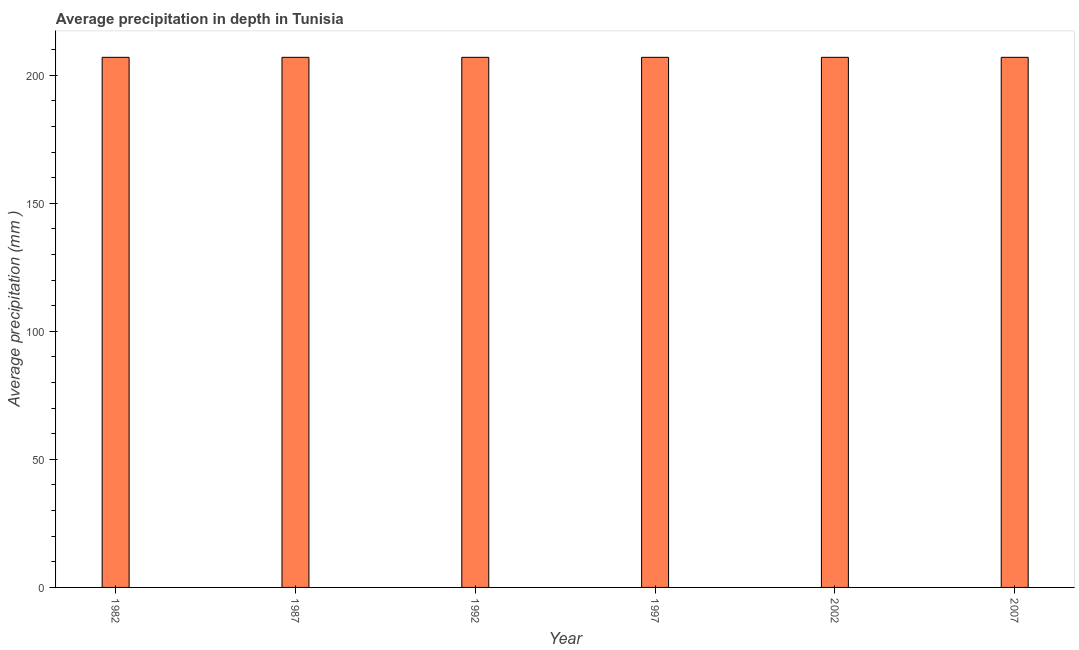Does the graph contain grids?
Offer a very short reply. No. What is the title of the graph?
Make the answer very short. Average precipitation in depth in Tunisia. What is the label or title of the Y-axis?
Offer a very short reply. Average precipitation (mm ). What is the average precipitation in depth in 1992?
Offer a terse response. 207. Across all years, what is the maximum average precipitation in depth?
Provide a short and direct response. 207. Across all years, what is the minimum average precipitation in depth?
Make the answer very short. 207. In which year was the average precipitation in depth maximum?
Keep it short and to the point. 1982. What is the sum of the average precipitation in depth?
Ensure brevity in your answer.  1242. What is the average average precipitation in depth per year?
Provide a short and direct response. 207. What is the median average precipitation in depth?
Give a very brief answer. 207. In how many years, is the average precipitation in depth greater than 110 mm?
Ensure brevity in your answer.  6. What is the difference between the highest and the lowest average precipitation in depth?
Your answer should be very brief. 0. How many bars are there?
Make the answer very short. 6. What is the Average precipitation (mm ) in 1982?
Ensure brevity in your answer.  207. What is the Average precipitation (mm ) of 1987?
Give a very brief answer. 207. What is the Average precipitation (mm ) of 1992?
Keep it short and to the point. 207. What is the Average precipitation (mm ) of 1997?
Your answer should be compact. 207. What is the Average precipitation (mm ) of 2002?
Offer a very short reply. 207. What is the Average precipitation (mm ) of 2007?
Provide a succinct answer. 207. What is the difference between the Average precipitation (mm ) in 1982 and 1987?
Make the answer very short. 0. What is the difference between the Average precipitation (mm ) in 1982 and 1992?
Your answer should be very brief. 0. What is the difference between the Average precipitation (mm ) in 1982 and 2002?
Provide a succinct answer. 0. What is the difference between the Average precipitation (mm ) in 1992 and 1997?
Offer a very short reply. 0. What is the difference between the Average precipitation (mm ) in 1992 and 2002?
Provide a short and direct response. 0. What is the difference between the Average precipitation (mm ) in 1997 and 2002?
Keep it short and to the point. 0. What is the difference between the Average precipitation (mm ) in 2002 and 2007?
Your response must be concise. 0. What is the ratio of the Average precipitation (mm ) in 1982 to that in 1987?
Keep it short and to the point. 1. What is the ratio of the Average precipitation (mm ) in 1982 to that in 1992?
Provide a short and direct response. 1. What is the ratio of the Average precipitation (mm ) in 1982 to that in 1997?
Ensure brevity in your answer.  1. What is the ratio of the Average precipitation (mm ) in 1987 to that in 1992?
Provide a succinct answer. 1. What is the ratio of the Average precipitation (mm ) in 1992 to that in 1997?
Make the answer very short. 1. What is the ratio of the Average precipitation (mm ) in 1992 to that in 2007?
Offer a terse response. 1. What is the ratio of the Average precipitation (mm ) in 1997 to that in 2002?
Offer a very short reply. 1. What is the ratio of the Average precipitation (mm ) in 1997 to that in 2007?
Ensure brevity in your answer.  1. 